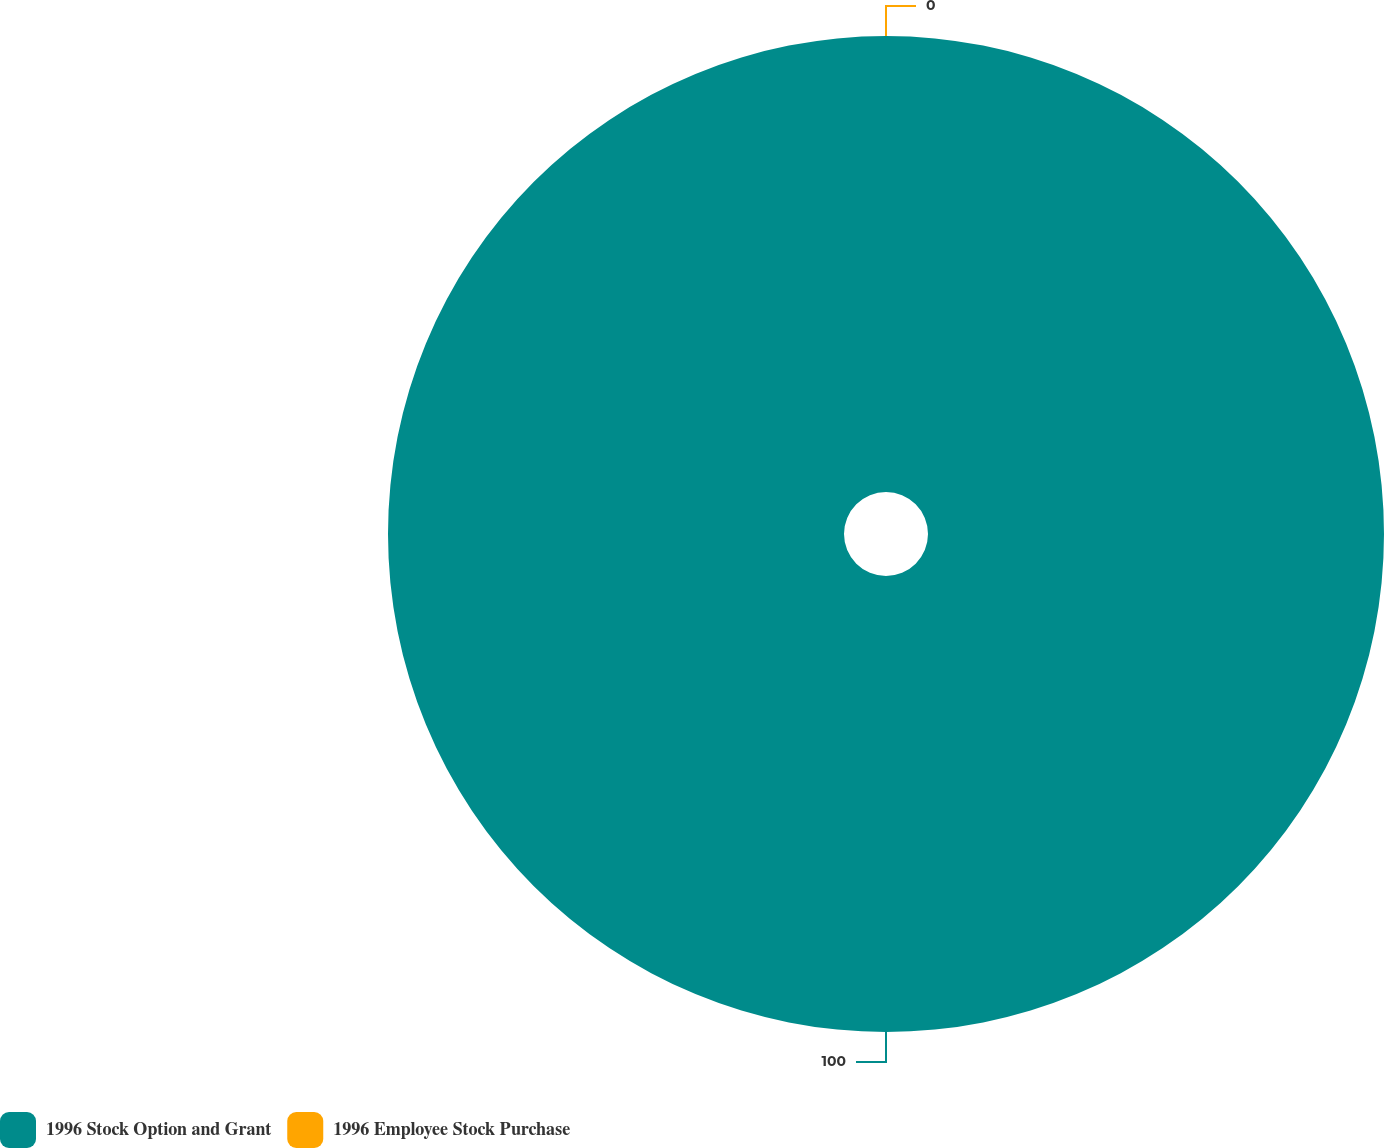<chart> <loc_0><loc_0><loc_500><loc_500><pie_chart><fcel>1996 Stock Option and Grant<fcel>1996 Employee Stock Purchase<nl><fcel>100.0%<fcel>0.0%<nl></chart> 